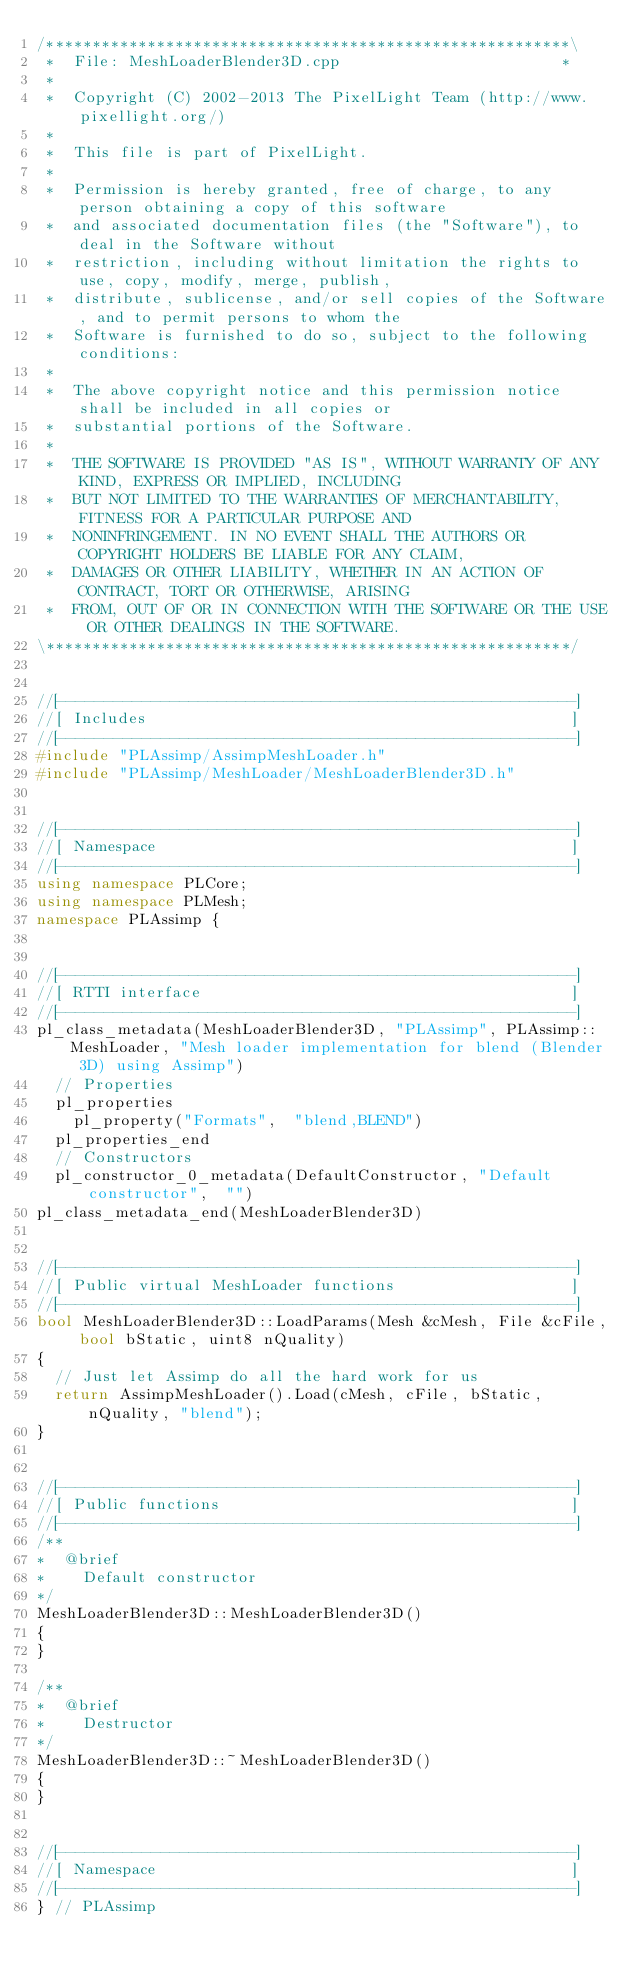<code> <loc_0><loc_0><loc_500><loc_500><_C++_>/*********************************************************\
 *  File: MeshLoaderBlender3D.cpp                        *
 *
 *  Copyright (C) 2002-2013 The PixelLight Team (http://www.pixellight.org/)
 *
 *  This file is part of PixelLight.
 *
 *  Permission is hereby granted, free of charge, to any person obtaining a copy of this software
 *  and associated documentation files (the "Software"), to deal in the Software without
 *  restriction, including without limitation the rights to use, copy, modify, merge, publish,
 *  distribute, sublicense, and/or sell copies of the Software, and to permit persons to whom the
 *  Software is furnished to do so, subject to the following conditions:
 *
 *  The above copyright notice and this permission notice shall be included in all copies or
 *  substantial portions of the Software.
 *
 *  THE SOFTWARE IS PROVIDED "AS IS", WITHOUT WARRANTY OF ANY KIND, EXPRESS OR IMPLIED, INCLUDING
 *  BUT NOT LIMITED TO THE WARRANTIES OF MERCHANTABILITY, FITNESS FOR A PARTICULAR PURPOSE AND
 *  NONINFRINGEMENT. IN NO EVENT SHALL THE AUTHORS OR COPYRIGHT HOLDERS BE LIABLE FOR ANY CLAIM,
 *  DAMAGES OR OTHER LIABILITY, WHETHER IN AN ACTION OF CONTRACT, TORT OR OTHERWISE, ARISING
 *  FROM, OUT OF OR IN CONNECTION WITH THE SOFTWARE OR THE USE OR OTHER DEALINGS IN THE SOFTWARE.
\*********************************************************/


//[-------------------------------------------------------]
//[ Includes                                              ]
//[-------------------------------------------------------]
#include "PLAssimp/AssimpMeshLoader.h"
#include "PLAssimp/MeshLoader/MeshLoaderBlender3D.h"


//[-------------------------------------------------------]
//[ Namespace                                             ]
//[-------------------------------------------------------]
using namespace PLCore;
using namespace PLMesh;
namespace PLAssimp {


//[-------------------------------------------------------]
//[ RTTI interface                                        ]
//[-------------------------------------------------------]
pl_class_metadata(MeshLoaderBlender3D, "PLAssimp", PLAssimp::MeshLoader, "Mesh loader implementation for blend (Blender 3D) using Assimp")
	// Properties
	pl_properties
		pl_property("Formats",	"blend,BLEND")
	pl_properties_end
	// Constructors
	pl_constructor_0_metadata(DefaultConstructor,	"Default constructor",	"")
pl_class_metadata_end(MeshLoaderBlender3D)


//[-------------------------------------------------------]
//[ Public virtual MeshLoader functions                   ]
//[-------------------------------------------------------]
bool MeshLoaderBlender3D::LoadParams(Mesh &cMesh, File &cFile, bool bStatic, uint8 nQuality)
{
	// Just let Assimp do all the hard work for us
	return AssimpMeshLoader().Load(cMesh, cFile, bStatic, nQuality, "blend");
}


//[-------------------------------------------------------]
//[ Public functions                                      ]
//[-------------------------------------------------------]
/**
*  @brief
*    Default constructor
*/
MeshLoaderBlender3D::MeshLoaderBlender3D()
{
}

/**
*  @brief
*    Destructor
*/
MeshLoaderBlender3D::~MeshLoaderBlender3D()
{
}


//[-------------------------------------------------------]
//[ Namespace                                             ]
//[-------------------------------------------------------]
} // PLAssimp
</code> 